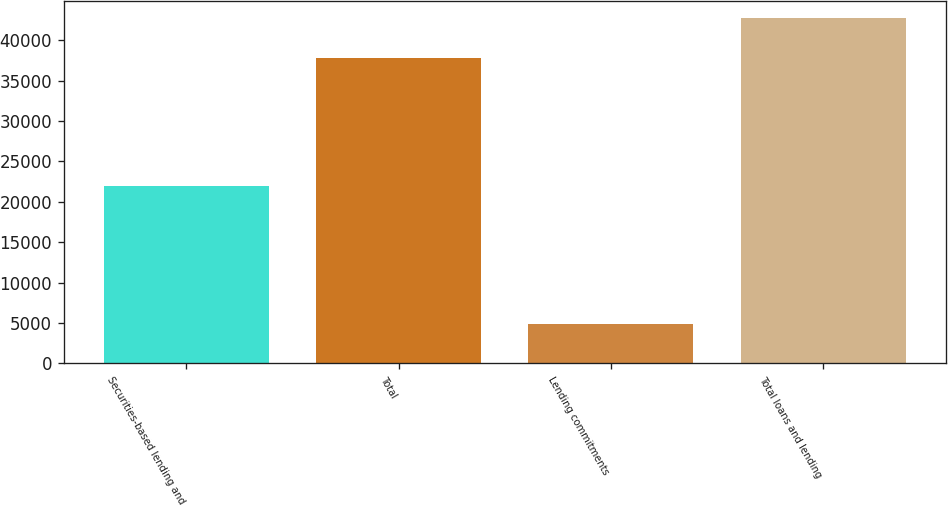Convert chart. <chart><loc_0><loc_0><loc_500><loc_500><bar_chart><fcel>Securities-based lending and<fcel>Total<fcel>Lending commitments<fcel>Total loans and lending<nl><fcel>21997<fcel>37822<fcel>4914<fcel>42736<nl></chart> 